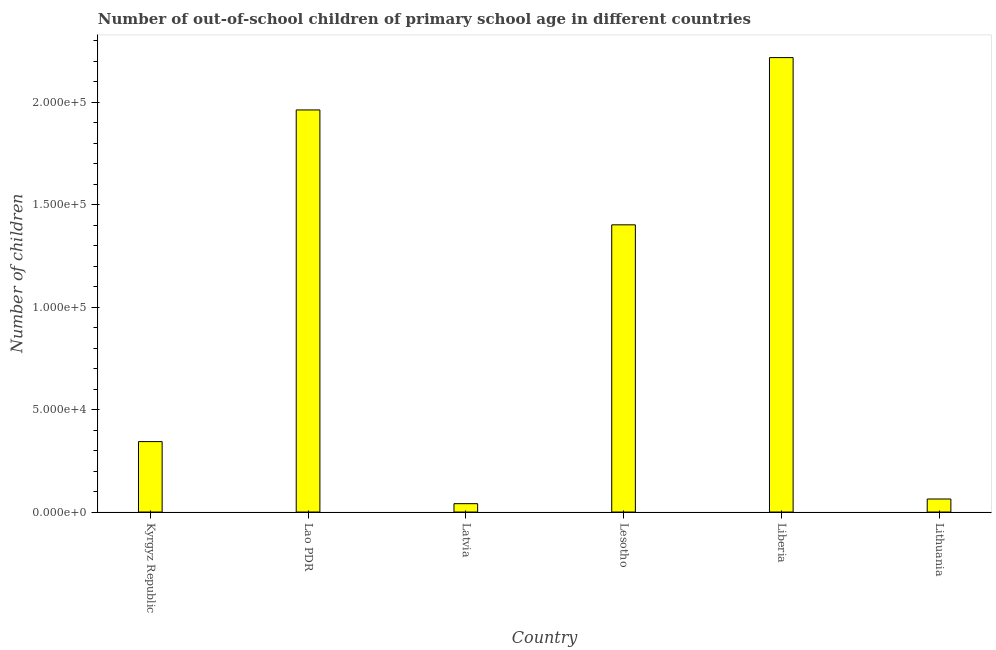What is the title of the graph?
Make the answer very short. Number of out-of-school children of primary school age in different countries. What is the label or title of the X-axis?
Keep it short and to the point. Country. What is the label or title of the Y-axis?
Your answer should be very brief. Number of children. What is the number of out-of-school children in Latvia?
Offer a terse response. 4076. Across all countries, what is the maximum number of out-of-school children?
Offer a terse response. 2.22e+05. Across all countries, what is the minimum number of out-of-school children?
Your response must be concise. 4076. In which country was the number of out-of-school children maximum?
Provide a succinct answer. Liberia. In which country was the number of out-of-school children minimum?
Offer a very short reply. Latvia. What is the sum of the number of out-of-school children?
Offer a terse response. 6.03e+05. What is the difference between the number of out-of-school children in Kyrgyz Republic and Lesotho?
Your answer should be compact. -1.06e+05. What is the average number of out-of-school children per country?
Keep it short and to the point. 1.01e+05. What is the median number of out-of-school children?
Keep it short and to the point. 8.73e+04. In how many countries, is the number of out-of-school children greater than 100000 ?
Provide a succinct answer. 3. What is the ratio of the number of out-of-school children in Kyrgyz Republic to that in Lesotho?
Your response must be concise. 0.24. Is the number of out-of-school children in Kyrgyz Republic less than that in Liberia?
Provide a succinct answer. Yes. What is the difference between the highest and the second highest number of out-of-school children?
Keep it short and to the point. 2.56e+04. What is the difference between the highest and the lowest number of out-of-school children?
Give a very brief answer. 2.18e+05. How many countries are there in the graph?
Give a very brief answer. 6. What is the difference between two consecutive major ticks on the Y-axis?
Your response must be concise. 5.00e+04. Are the values on the major ticks of Y-axis written in scientific E-notation?
Make the answer very short. Yes. What is the Number of children of Kyrgyz Republic?
Offer a very short reply. 3.44e+04. What is the Number of children of Lao PDR?
Provide a succinct answer. 1.96e+05. What is the Number of children in Latvia?
Your answer should be compact. 4076. What is the Number of children in Lesotho?
Offer a very short reply. 1.40e+05. What is the Number of children in Liberia?
Give a very brief answer. 2.22e+05. What is the Number of children in Lithuania?
Make the answer very short. 6356. What is the difference between the Number of children in Kyrgyz Republic and Lao PDR?
Offer a terse response. -1.62e+05. What is the difference between the Number of children in Kyrgyz Republic and Latvia?
Offer a terse response. 3.03e+04. What is the difference between the Number of children in Kyrgyz Republic and Lesotho?
Provide a succinct answer. -1.06e+05. What is the difference between the Number of children in Kyrgyz Republic and Liberia?
Your response must be concise. -1.87e+05. What is the difference between the Number of children in Kyrgyz Republic and Lithuania?
Offer a very short reply. 2.80e+04. What is the difference between the Number of children in Lao PDR and Latvia?
Offer a very short reply. 1.92e+05. What is the difference between the Number of children in Lao PDR and Lesotho?
Your answer should be compact. 5.61e+04. What is the difference between the Number of children in Lao PDR and Liberia?
Provide a succinct answer. -2.56e+04. What is the difference between the Number of children in Lao PDR and Lithuania?
Offer a very short reply. 1.90e+05. What is the difference between the Number of children in Latvia and Lesotho?
Offer a very short reply. -1.36e+05. What is the difference between the Number of children in Latvia and Liberia?
Your answer should be very brief. -2.18e+05. What is the difference between the Number of children in Latvia and Lithuania?
Your response must be concise. -2280. What is the difference between the Number of children in Lesotho and Liberia?
Give a very brief answer. -8.16e+04. What is the difference between the Number of children in Lesotho and Lithuania?
Keep it short and to the point. 1.34e+05. What is the difference between the Number of children in Liberia and Lithuania?
Give a very brief answer. 2.15e+05. What is the ratio of the Number of children in Kyrgyz Republic to that in Lao PDR?
Provide a succinct answer. 0.17. What is the ratio of the Number of children in Kyrgyz Republic to that in Latvia?
Ensure brevity in your answer.  8.44. What is the ratio of the Number of children in Kyrgyz Republic to that in Lesotho?
Make the answer very short. 0.24. What is the ratio of the Number of children in Kyrgyz Republic to that in Liberia?
Provide a short and direct response. 0.15. What is the ratio of the Number of children in Kyrgyz Republic to that in Lithuania?
Give a very brief answer. 5.41. What is the ratio of the Number of children in Lao PDR to that in Latvia?
Offer a terse response. 48.16. What is the ratio of the Number of children in Lao PDR to that in Liberia?
Keep it short and to the point. 0.89. What is the ratio of the Number of children in Lao PDR to that in Lithuania?
Offer a terse response. 30.88. What is the ratio of the Number of children in Latvia to that in Lesotho?
Offer a terse response. 0.03. What is the ratio of the Number of children in Latvia to that in Liberia?
Provide a short and direct response. 0.02. What is the ratio of the Number of children in Latvia to that in Lithuania?
Ensure brevity in your answer.  0.64. What is the ratio of the Number of children in Lesotho to that in Liberia?
Provide a short and direct response. 0.63. What is the ratio of the Number of children in Lesotho to that in Lithuania?
Ensure brevity in your answer.  22.06. What is the ratio of the Number of children in Liberia to that in Lithuania?
Provide a succinct answer. 34.9. 